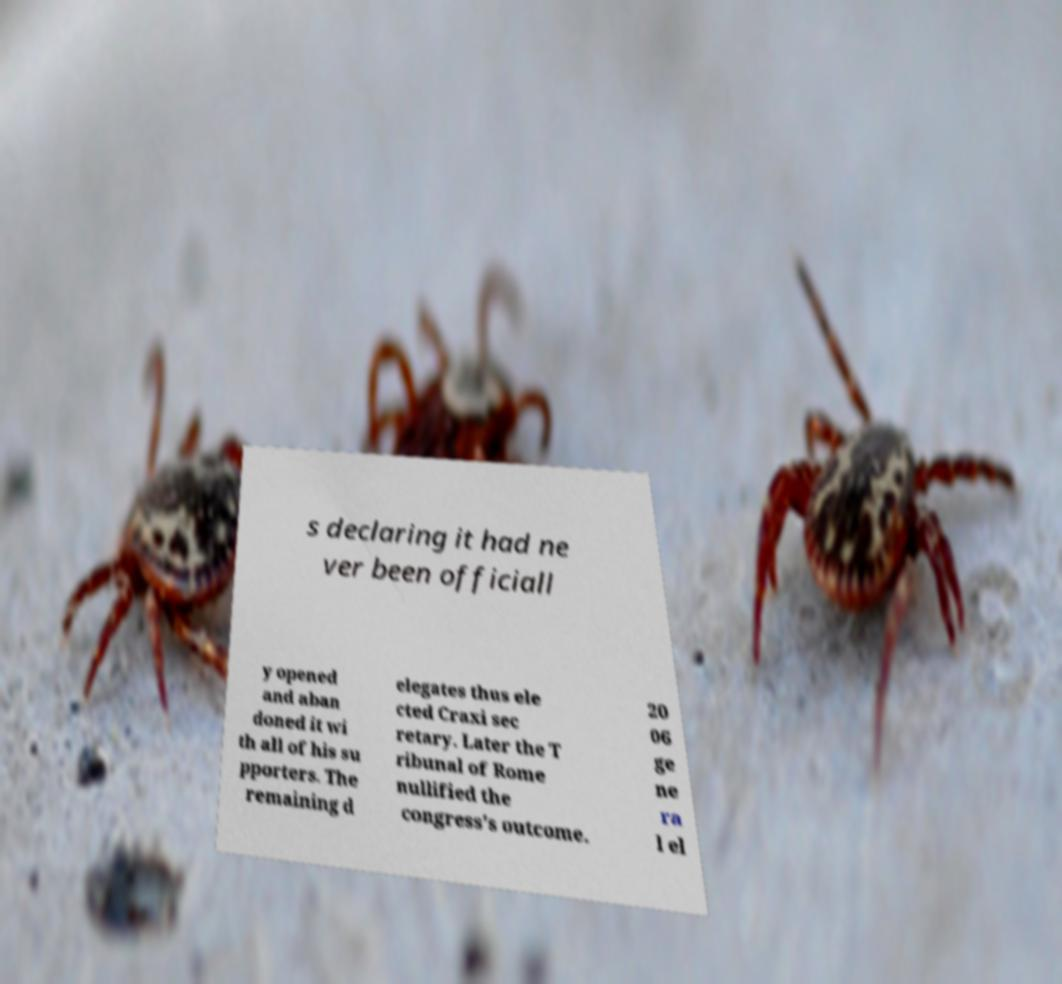For documentation purposes, I need the text within this image transcribed. Could you provide that? s declaring it had ne ver been officiall y opened and aban doned it wi th all of his su pporters. The remaining d elegates thus ele cted Craxi sec retary. Later the T ribunal of Rome nullified the congress's outcome. 20 06 ge ne ra l el 